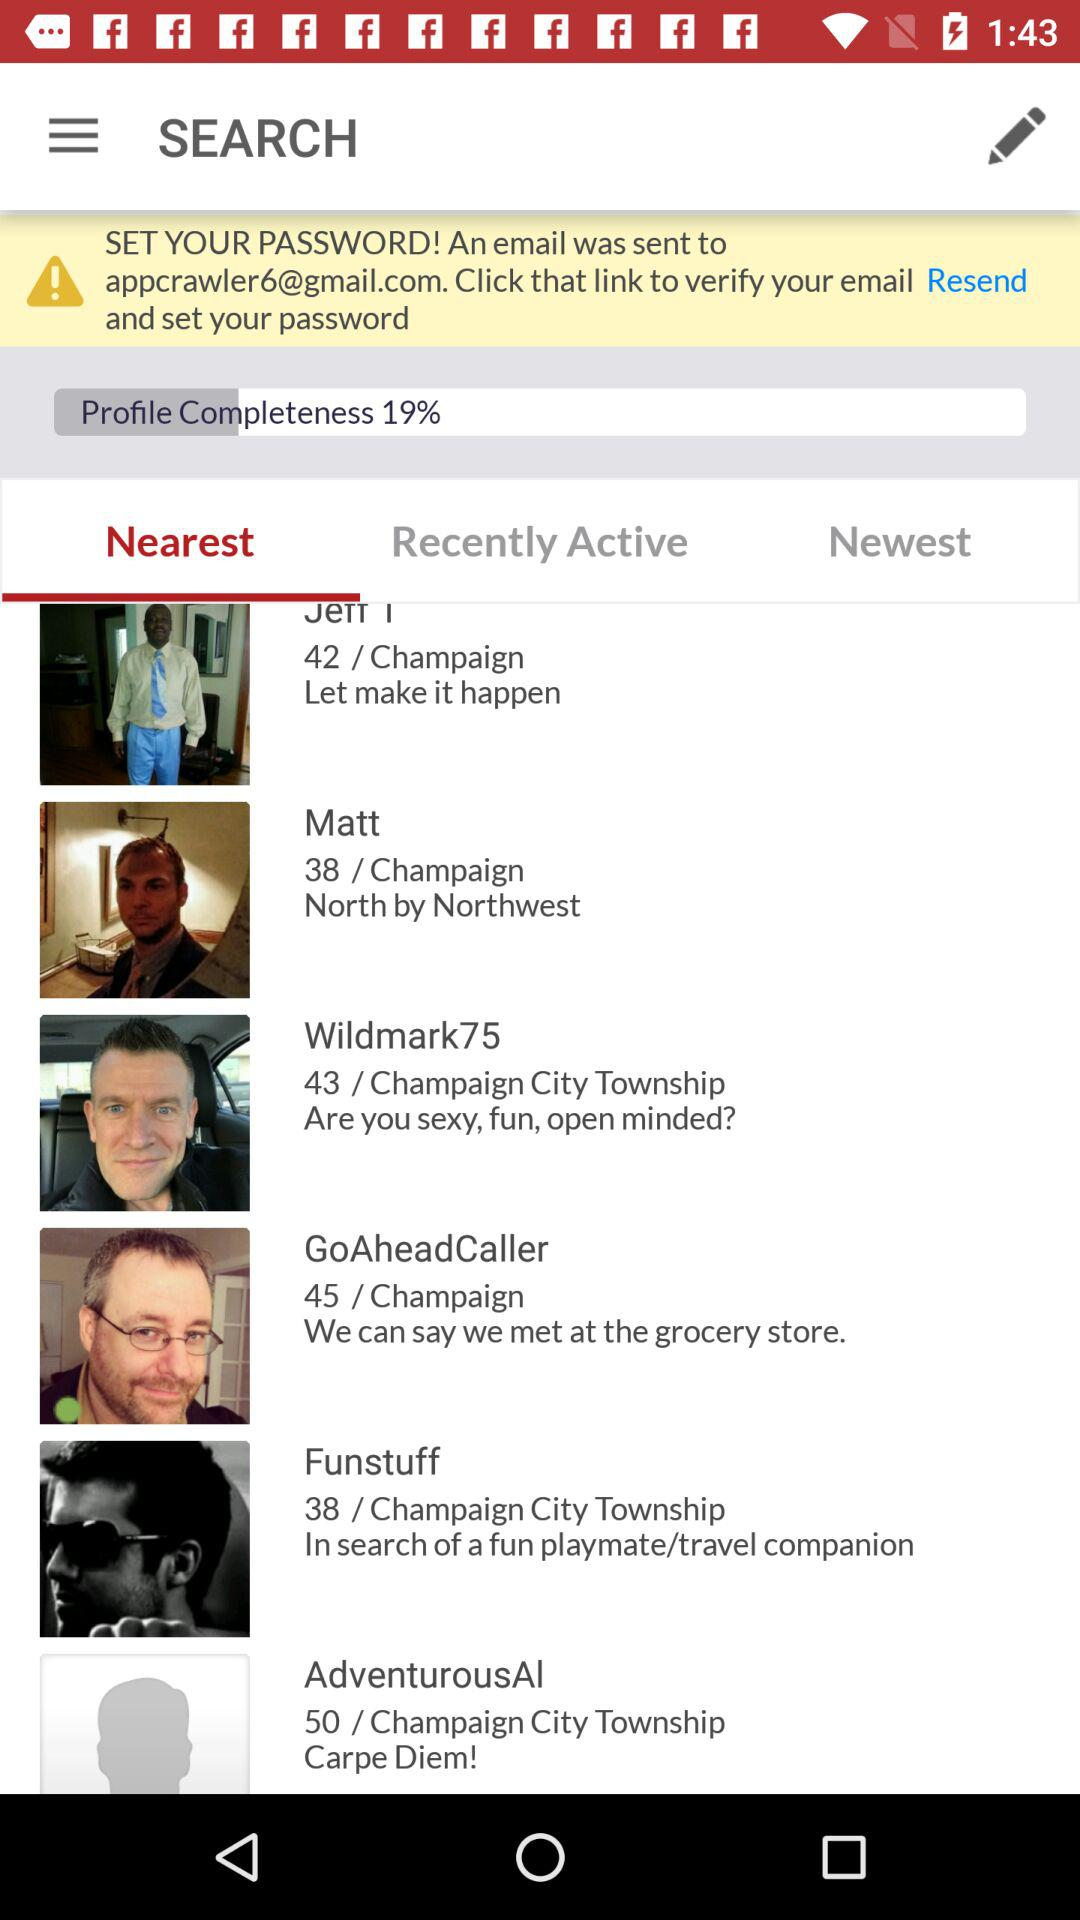What is the percentage of completion of the user's profile?
Answer the question using a single word or phrase. 19% 